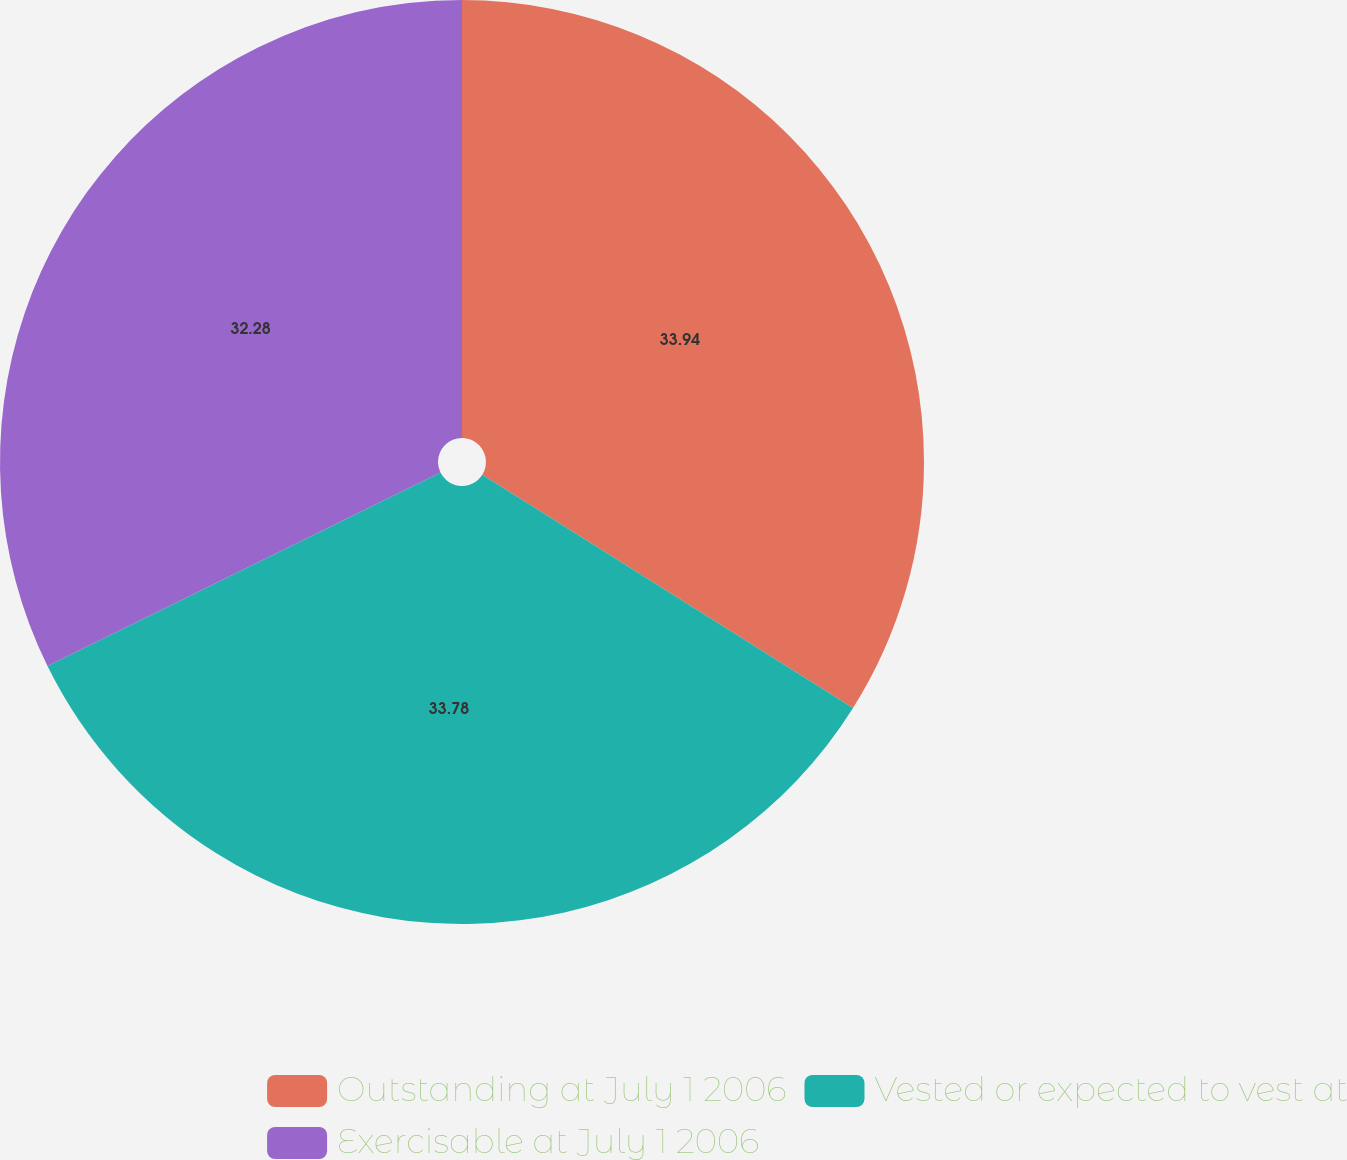Convert chart. <chart><loc_0><loc_0><loc_500><loc_500><pie_chart><fcel>Outstanding at July 1 2006<fcel>Vested or expected to vest at<fcel>Exercisable at July 1 2006<nl><fcel>33.94%<fcel>33.78%<fcel>32.28%<nl></chart> 